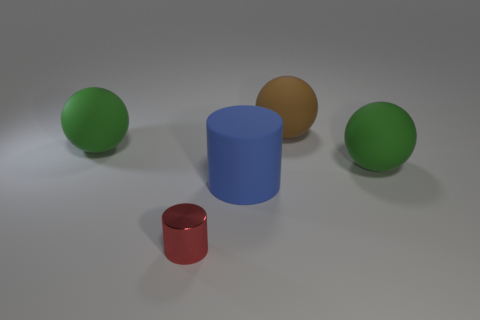Subtract all green cylinders. How many green balls are left? 2 Subtract all green balls. How many balls are left? 1 Add 3 green things. How many objects exist? 8 Subtract all balls. How many objects are left? 2 Subtract 0 purple balls. How many objects are left? 5 Subtract all gray cylinders. Subtract all cyan balls. How many cylinders are left? 2 Subtract all large blue cylinders. Subtract all green things. How many objects are left? 2 Add 4 rubber cylinders. How many rubber cylinders are left? 5 Add 2 gray shiny cylinders. How many gray shiny cylinders exist? 2 